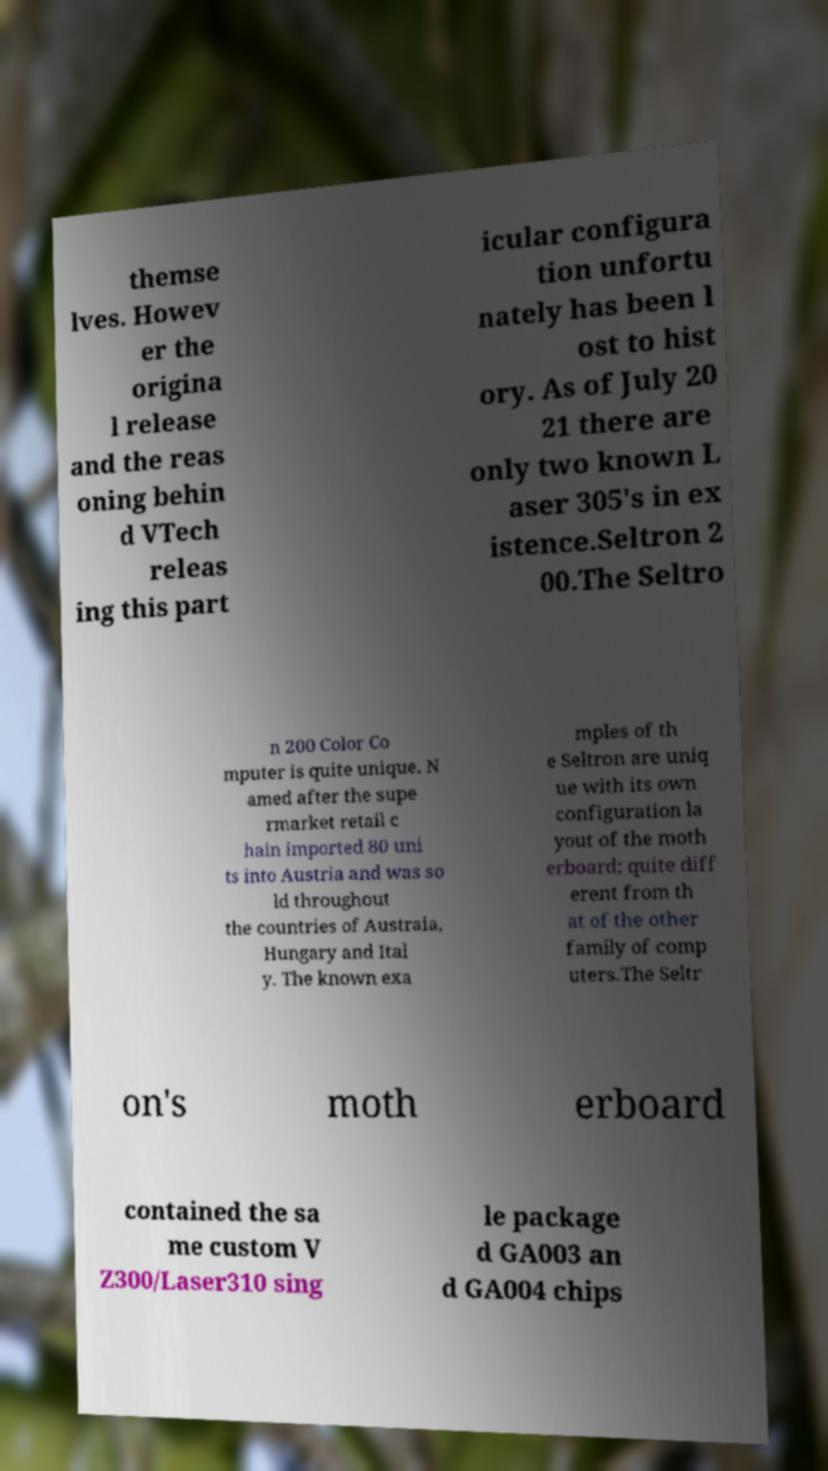For documentation purposes, I need the text within this image transcribed. Could you provide that? themse lves. Howev er the origina l release and the reas oning behin d VTech releas ing this part icular configura tion unfortu nately has been l ost to hist ory. As of July 20 21 there are only two known L aser 305's in ex istence.Seltron 2 00.The Seltro n 200 Color Co mputer is quite unique. N amed after the supe rmarket retail c hain imported 80 uni ts into Austria and was so ld throughout the countries of Austraia, Hungary and Ital y. The known exa mples of th e Seltron are uniq ue with its own configuration la yout of the moth erboard; quite diff erent from th at of the other family of comp uters.The Seltr on's moth erboard contained the sa me custom V Z300/Laser310 sing le package d GA003 an d GA004 chips 